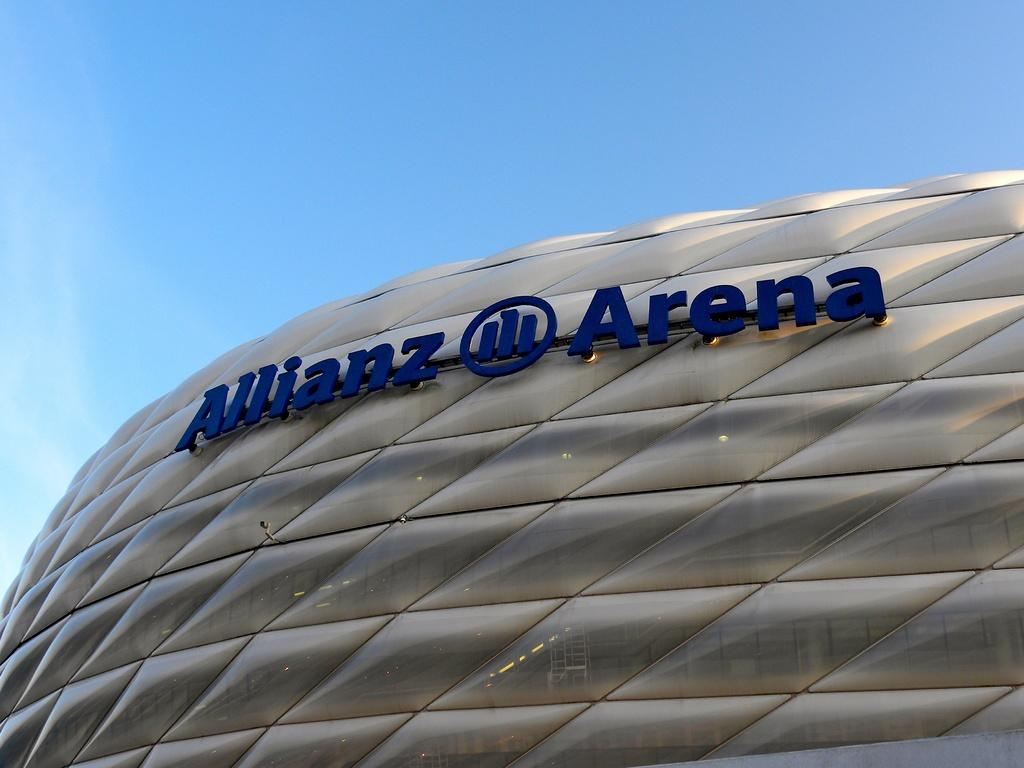What color is the hoarding on the right side of the image? The hoarding is violet in color. How is the hoarding positioned in relation to the building? The hoarding is attached to the glass windows of a building. What can be seen in the background of the image? There are clouds in the background of the image. What is the color of the sky in the image? The sky is blue in the image. What type of cakes are being served in the morning in the image? There are no cakes or any indication of a morning scene in the image; it features a violet hoarding attached to a building with clouds and a blue sky in the background. 